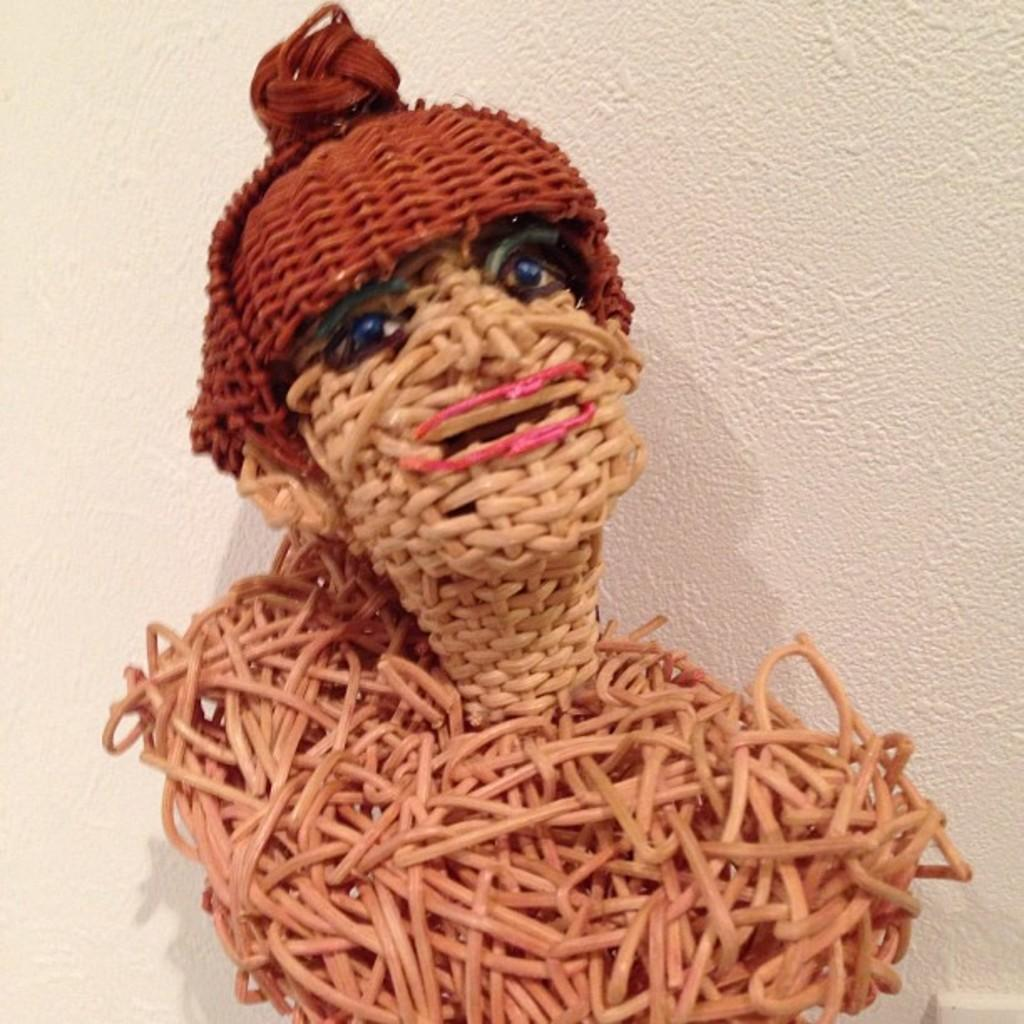What type of toy is present in the image? There is a toy made of wooden splints in the image. What can be seen in the background of the image? There is a wall visible in the background of the image. What type of vegetable is growing on the wall in the image? There are no vegetables present in the image; the wall is a part of the background and does not have any vegetation growing on it. 